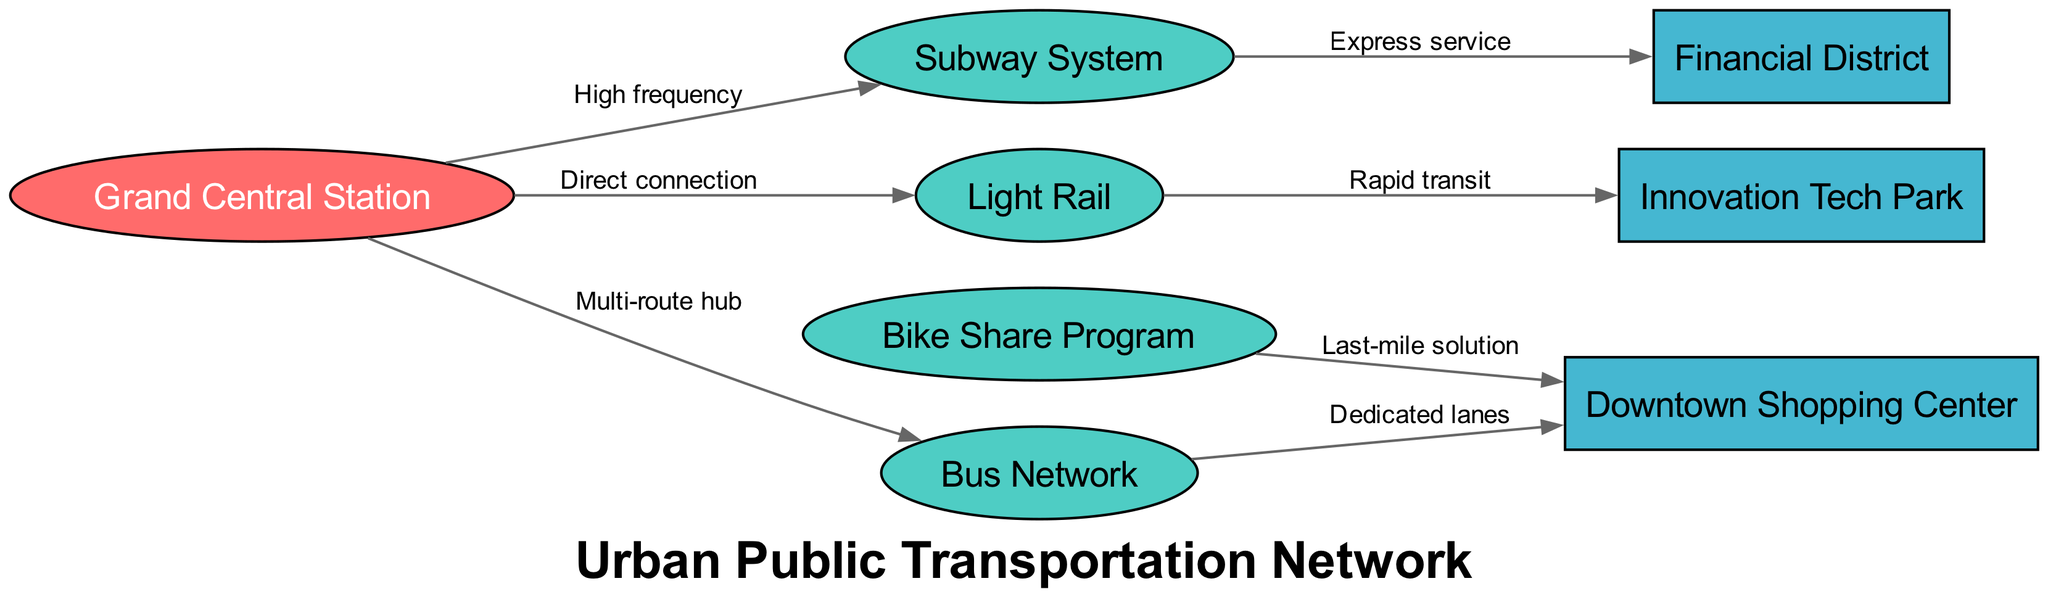What is the major hub in this transportation network? The diagram features a node labeled "Grand Central Station" identified as the major hub of the transportation system, which serves as a central point where various transit modes converge.
Answer: Grand Central Station How many transit modes are represented in the diagram? There are four transit modes shown in the diagram: Subway System, Bus Network, Light Rail, and Bike Share Program, making a total of four distinct modes of transit.
Answer: 4 Which destination is accessed directly by the light rail? The light rail has a direct connection to "Innovation Tech Park," as indicated by the edge connecting these two nodes in the diagram.
Answer: Innovation Tech Park What type of service does the subway provide to the financial district? The subway provides "Express service" to the financial district, as denoted by the label on the edge connecting the subway to the financial district node.
Answer: Express service What is the purpose of the bike share program in relation to the shopping center? The bike share program serves as a "Last-mile solution" for reaching the shopping center, which is specified on the edge connecting these two nodes.
Answer: Last-mile solution Which transit mode serves as a multi-route hub at the central station? The bus network is identified as the transit mode that serves as a multi-route hub at Grand Central Station, as indicated by the edge connecting these two nodes and its labeled relationship.
Answer: Bus Network How is the bus network linked to the downtown shopping center? The bus network is linked to the downtown shopping center through dedicated lanes, as specified by the label on the edge connecting the bus network to the shopping center.
Answer: Dedicated lanes What type of nodes connect to the central station? The central station connects to three types of transit modes: Subway System, Bus Network, and Light Rail, which are all labeled as transit modes in the diagram.
Answer: Three transit modes What is the connection quality between Grand Central Station and the subway system? The connection quality between Grand Central Station and the subway system is described as "High frequency," indicating a robust and frequent transportation link.
Answer: High frequency 